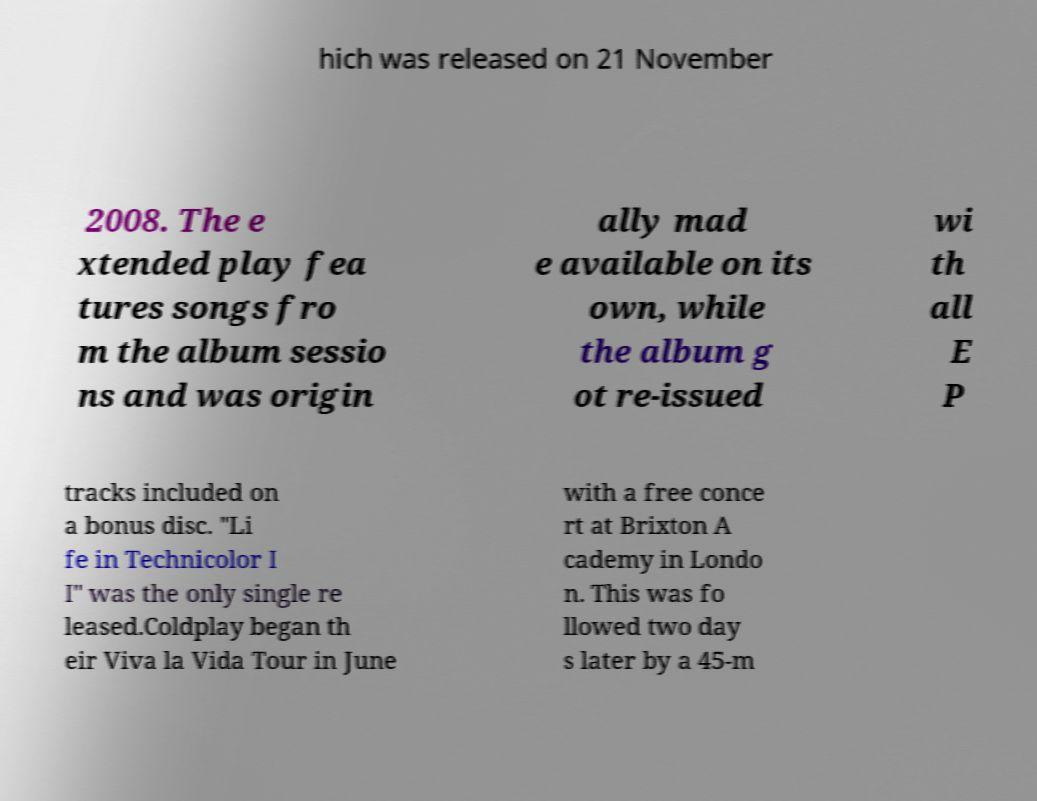Can you read and provide the text displayed in the image?This photo seems to have some interesting text. Can you extract and type it out for me? hich was released on 21 November 2008. The e xtended play fea tures songs fro m the album sessio ns and was origin ally mad e available on its own, while the album g ot re-issued wi th all E P tracks included on a bonus disc. "Li fe in Technicolor I I" was the only single re leased.Coldplay began th eir Viva la Vida Tour in June with a free conce rt at Brixton A cademy in Londo n. This was fo llowed two day s later by a 45-m 